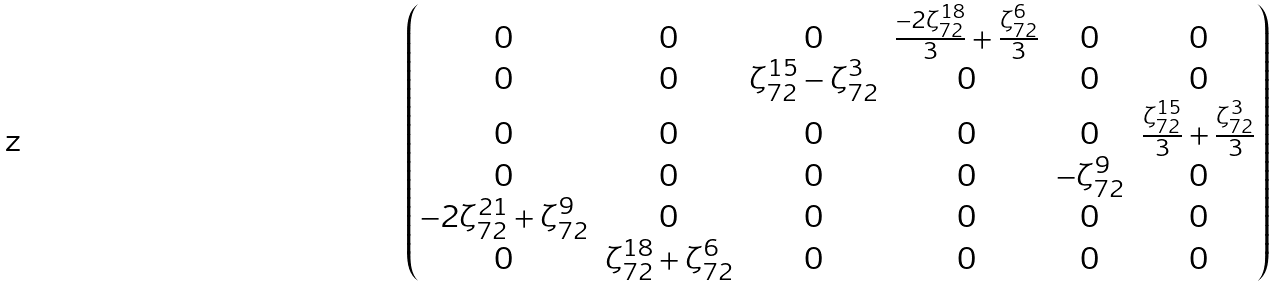Convert formula to latex. <formula><loc_0><loc_0><loc_500><loc_500>\begin{pmatrix} 0 & 0 & 0 & \frac { - 2 \zeta _ { 7 2 } ^ { 1 8 } } { 3 } + \frac { \zeta _ { 7 2 } ^ { 6 } } { 3 } & 0 & 0 \\ 0 & 0 & \zeta _ { 7 2 } ^ { 1 5 } - \zeta _ { 7 2 } ^ { 3 } & 0 & 0 & 0 \\ 0 & 0 & 0 & 0 & 0 & \frac { \zeta _ { 7 2 } ^ { 1 5 } } { 3 } + \frac { \zeta _ { 7 2 } ^ { 3 } } { 3 } \\ 0 & 0 & 0 & 0 & - \zeta _ { 7 2 } ^ { 9 } & 0 \\ - 2 \zeta _ { 7 2 } ^ { 2 1 } + \zeta _ { 7 2 } ^ { 9 } & 0 & 0 & 0 & 0 & 0 \\ 0 & \zeta _ { 7 2 } ^ { 1 8 } + \zeta _ { 7 2 } ^ { 6 } & 0 & 0 & 0 & 0 \end{pmatrix}</formula> 